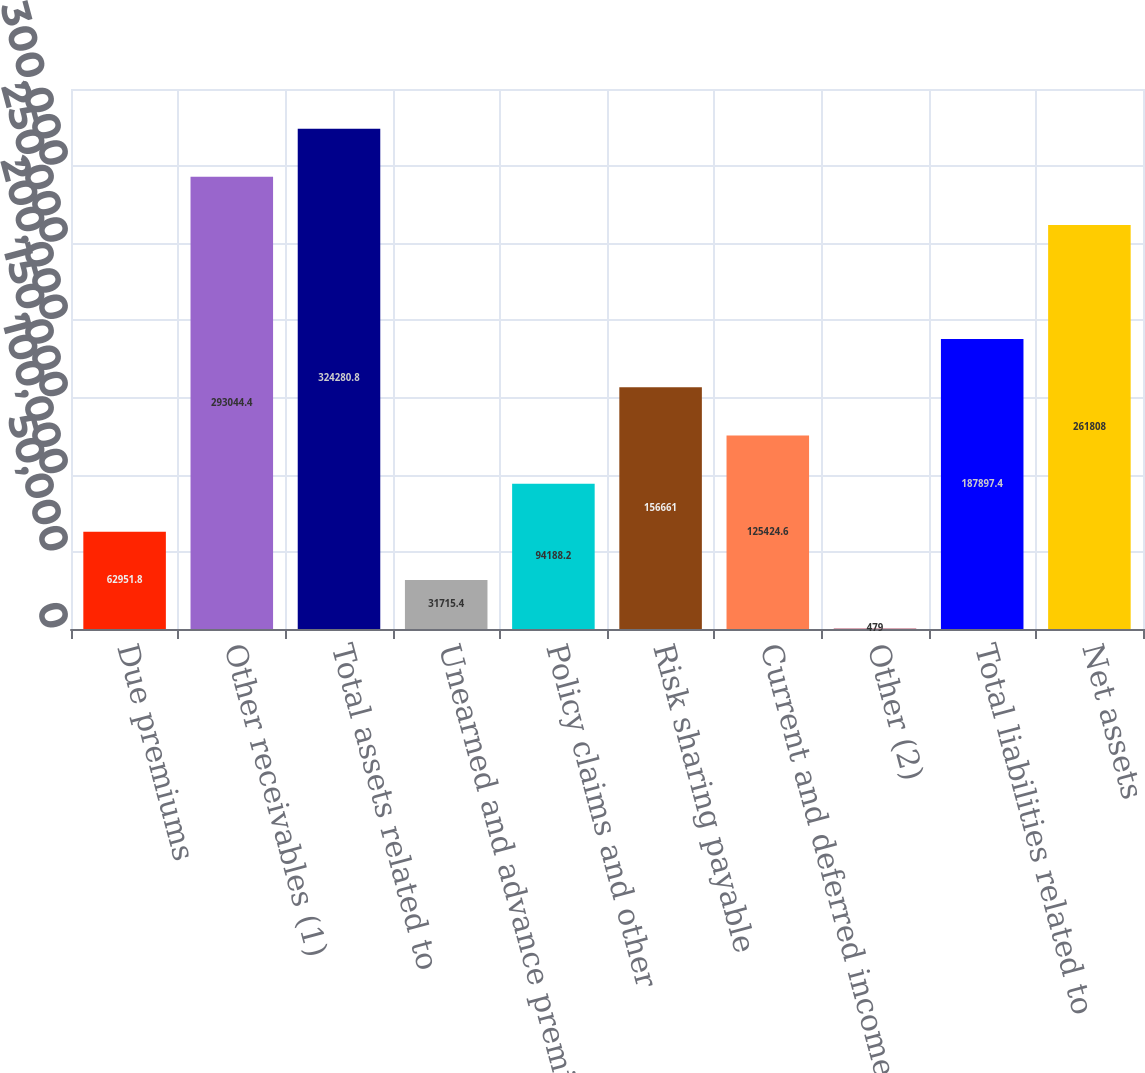Convert chart to OTSL. <chart><loc_0><loc_0><loc_500><loc_500><bar_chart><fcel>Due premiums<fcel>Other receivables (1)<fcel>Total assets related to<fcel>Unearned and advance premiums<fcel>Policy claims and other<fcel>Risk sharing payable<fcel>Current and deferred income<fcel>Other (2)<fcel>Total liabilities related to<fcel>Net assets<nl><fcel>62951.8<fcel>293044<fcel>324281<fcel>31715.4<fcel>94188.2<fcel>156661<fcel>125425<fcel>479<fcel>187897<fcel>261808<nl></chart> 